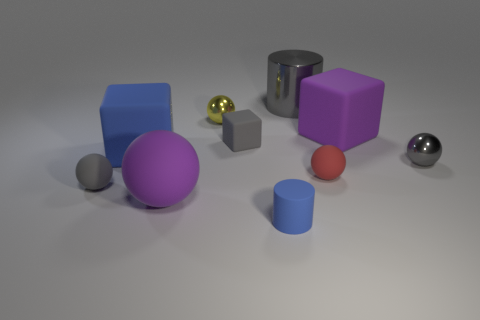Subtract all gray spheres. How many spheres are left? 3 Subtract all yellow blocks. How many gray balls are left? 2 Subtract all blue cubes. How many cubes are left? 2 Subtract all blocks. How many objects are left? 7 Add 2 tiny cyan rubber cubes. How many tiny cyan rubber cubes exist? 2 Subtract 1 blue cubes. How many objects are left? 9 Subtract all purple blocks. Subtract all green balls. How many blocks are left? 2 Subtract all large purple things. Subtract all tiny cylinders. How many objects are left? 7 Add 4 large blue cubes. How many large blue cubes are left? 5 